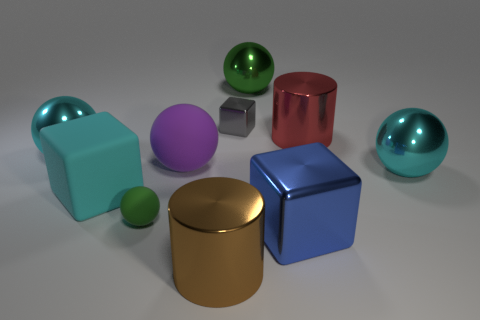Is the small block the same color as the large matte block?
Offer a terse response. No. Do the green ball that is behind the green matte sphere and the big cylinder that is left of the gray object have the same material?
Your answer should be compact. Yes. Are there any blue objects that have the same size as the purple ball?
Ensure brevity in your answer.  Yes. What size is the cylinder to the left of the small object that is behind the big rubber cube?
Provide a succinct answer. Large. What number of big shiny things are the same color as the rubber cube?
Keep it short and to the point. 2. There is a large cyan metal object that is on the right side of the big cyan shiny thing that is on the left side of the big brown thing; what shape is it?
Ensure brevity in your answer.  Sphere. What number of small cyan balls are made of the same material as the blue block?
Provide a short and direct response. 0. There is a cyan thing that is right of the green rubber ball; what is it made of?
Provide a short and direct response. Metal. What shape is the green object that is behind the red metallic cylinder to the right of the cyan shiny sphere that is left of the large green object?
Provide a succinct answer. Sphere. There is a metallic ball that is left of the tiny green matte ball; is its color the same as the block on the left side of the purple rubber object?
Offer a very short reply. Yes. 